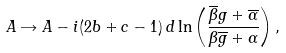Convert formula to latex. <formula><loc_0><loc_0><loc_500><loc_500>A \rightarrow A - i ( 2 b + c - 1 ) \, d \ln \left ( \frac { \overline { \beta } g + \overline { \alpha } } { \beta \overline { g } + \alpha } \right ) ,</formula> 